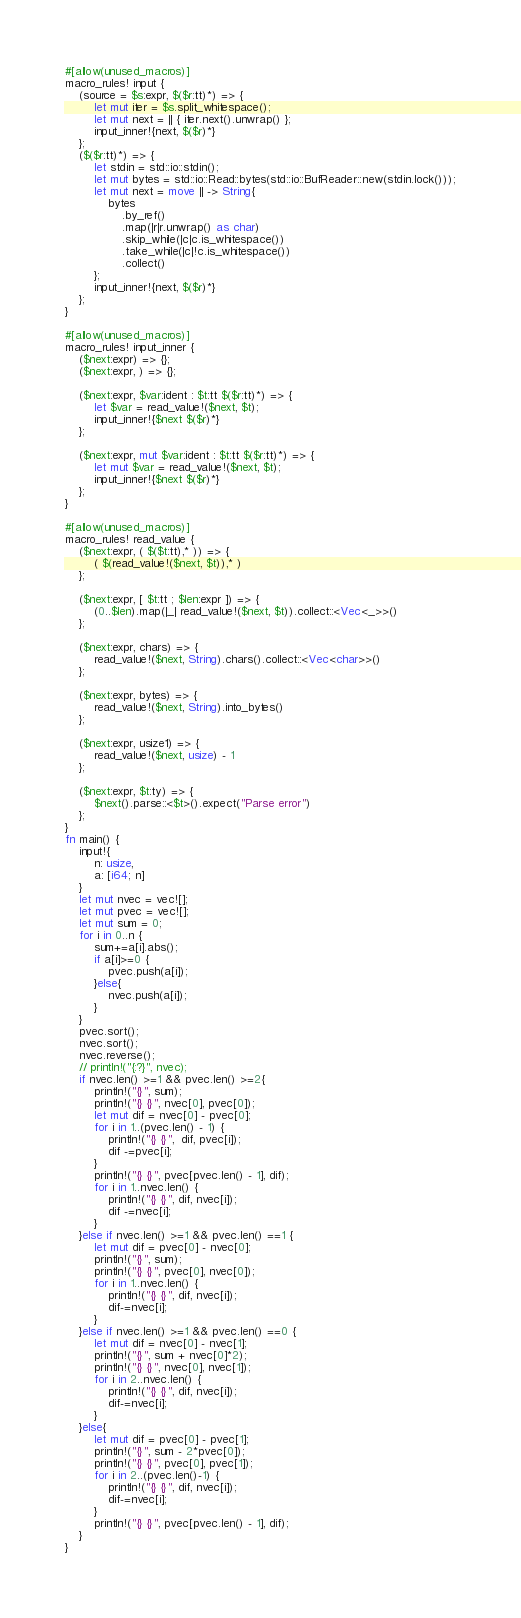<code> <loc_0><loc_0><loc_500><loc_500><_Rust_>#[allow(unused_macros)]
macro_rules! input {
    (source = $s:expr, $($r:tt)*) => {
        let mut iter = $s.split_whitespace();
        let mut next = || { iter.next().unwrap() };
        input_inner!{next, $($r)*}
    };
    ($($r:tt)*) => {
        let stdin = std::io::stdin();
        let mut bytes = std::io::Read::bytes(std::io::BufReader::new(stdin.lock()));
        let mut next = move || -> String{
            bytes
                .by_ref()
                .map(|r|r.unwrap() as char)
                .skip_while(|c|c.is_whitespace())
                .take_while(|c|!c.is_whitespace())
                .collect()
        };
        input_inner!{next, $($r)*}
    };
}

#[allow(unused_macros)]
macro_rules! input_inner {
    ($next:expr) => {};
    ($next:expr, ) => {};

    ($next:expr, $var:ident : $t:tt $($r:tt)*) => {
        let $var = read_value!($next, $t);
        input_inner!{$next $($r)*}
    };

    ($next:expr, mut $var:ident : $t:tt $($r:tt)*) => {
        let mut $var = read_value!($next, $t);
        input_inner!{$next $($r)*}
    };
}

#[allow(unused_macros)]
macro_rules! read_value {
    ($next:expr, ( $($t:tt),* )) => {
        ( $(read_value!($next, $t)),* )
    };

    ($next:expr, [ $t:tt ; $len:expr ]) => {
        (0..$len).map(|_| read_value!($next, $t)).collect::<Vec<_>>()
    };

    ($next:expr, chars) => {
        read_value!($next, String).chars().collect::<Vec<char>>()
    };

    ($next:expr, bytes) => {
        read_value!($next, String).into_bytes()
    };

    ($next:expr, usize1) => {
        read_value!($next, usize) - 1
    };

    ($next:expr, $t:ty) => {
        $next().parse::<$t>().expect("Parse error")
    };
}
fn main() {
    input!{
        n: usize,
        a: [i64; n]
    }
    let mut nvec = vec![];
    let mut pvec = vec![];
    let mut sum = 0;
    for i in 0..n {
        sum+=a[i].abs();
        if a[i]>=0 {
            pvec.push(a[i]);
        }else{
            nvec.push(a[i]);
        }
    }
    pvec.sort();
    nvec.sort();
    nvec.reverse();
    // println!("{:?}", nvec);
    if nvec.len() >=1 && pvec.len() >=2{
        println!("{}", sum);
        println!("{} {}", nvec[0], pvec[0]);
        let mut dif = nvec[0] - pvec[0];
        for i in 1..(pvec.len() - 1) {
            println!("{} {}",  dif, pvec[i]);
            dif -=pvec[i];
        }
        println!("{} {}", pvec[pvec.len() - 1], dif);
        for i in 1..nvec.len() {
            println!("{} {}", dif, nvec[i]);
            dif -=nvec[i];
        }
    }else if nvec.len() >=1 && pvec.len() ==1 {
        let mut dif = pvec[0] - nvec[0];
        println!("{}", sum);
        println!("{} {}", pvec[0], nvec[0]);
        for i in 1..nvec.len() {
            println!("{} {}", dif, nvec[i]);
            dif-=nvec[i];
        }
    }else if nvec.len() >=1 && pvec.len() ==0 {
        let mut dif = nvec[0] - nvec[1];
        println!("{}", sum + nvec[0]*2);
        println!("{} {}", nvec[0], nvec[1]);
        for i in 2..nvec.len() {
            println!("{} {}", dif, nvec[i]);
            dif-=nvec[i];
        }
    }else{
        let mut dif = pvec[0] - pvec[1];
        println!("{}", sum - 2*pvec[0]);
        println!("{} {}", pvec[0], pvec[1]);
        for i in 2..(pvec.len()-1) {
            println!("{} {}", dif, nvec[i]);
            dif-=nvec[i];
        }
        println!("{} {}", pvec[pvec.len() - 1], dif);
    }
}</code> 